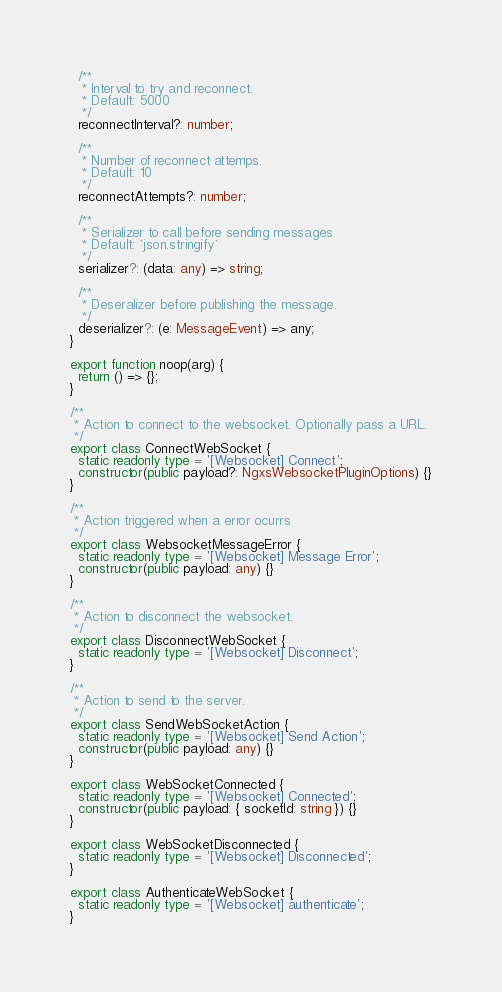Convert code to text. <code><loc_0><loc_0><loc_500><loc_500><_TypeScript_>
  /**
   * Interval to try and reconnect.
   * Default: 5000
   */
  reconnectInterval?: number;

  /**
   * Number of reconnect attemps.
   * Default: 10
   */
  reconnectAttempts?: number;

  /**
   * Serializer to call before sending messages
   * Default: `json.stringify`
   */
  serializer?: (data: any) => string;

  /**
   * Deseralizer before publishing the message.
   */
  deserializer?: (e: MessageEvent) => any;
}

export function noop(arg) {
  return () => {};
}

/**
 * Action to connect to the websocket. Optionally pass a URL.
 */
export class ConnectWebSocket {
  static readonly type = '[Websocket] Connect';
  constructor(public payload?: NgxsWebsocketPluginOptions) {}
}

/**
 * Action triggered when a error ocurrs
 */
export class WebsocketMessageError {
  static readonly type = '[Websocket] Message Error';
  constructor(public payload: any) {}
}

/**
 * Action to disconnect the websocket.
 */
export class DisconnectWebSocket {
  static readonly type = '[Websocket] Disconnect';
}

/**
 * Action to send to the server.
 */
export class SendWebSocketAction {
  static readonly type = '[Websocket] Send Action';
  constructor(public payload: any) {}
}

export class WebSocketConnected {
  static readonly type = '[Websocket] Connected';
  constructor(public payload: { socketId: string }) {}
}

export class WebSocketDisconnected {
  static readonly type = '[Websocket] Disconnected';
}

export class AuthenticateWebSocket {
  static readonly type = '[Websocket] authenticate';
}
</code> 